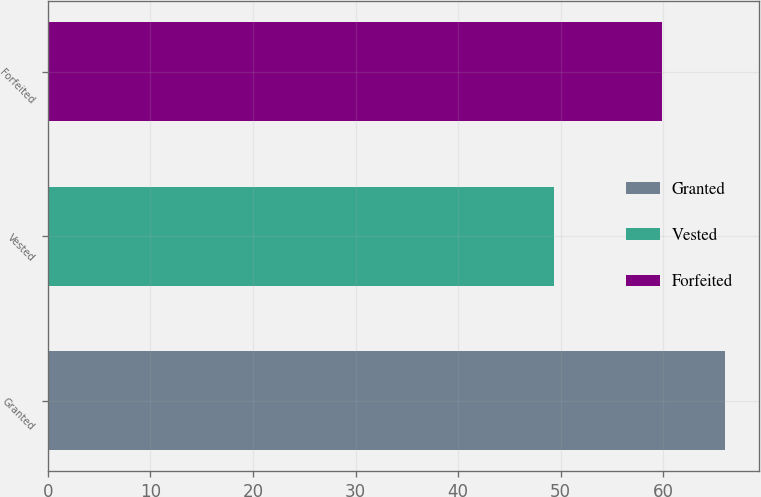Convert chart to OTSL. <chart><loc_0><loc_0><loc_500><loc_500><bar_chart><fcel>Granted<fcel>Vested<fcel>Forfeited<nl><fcel>66.05<fcel>49.39<fcel>59.91<nl></chart> 